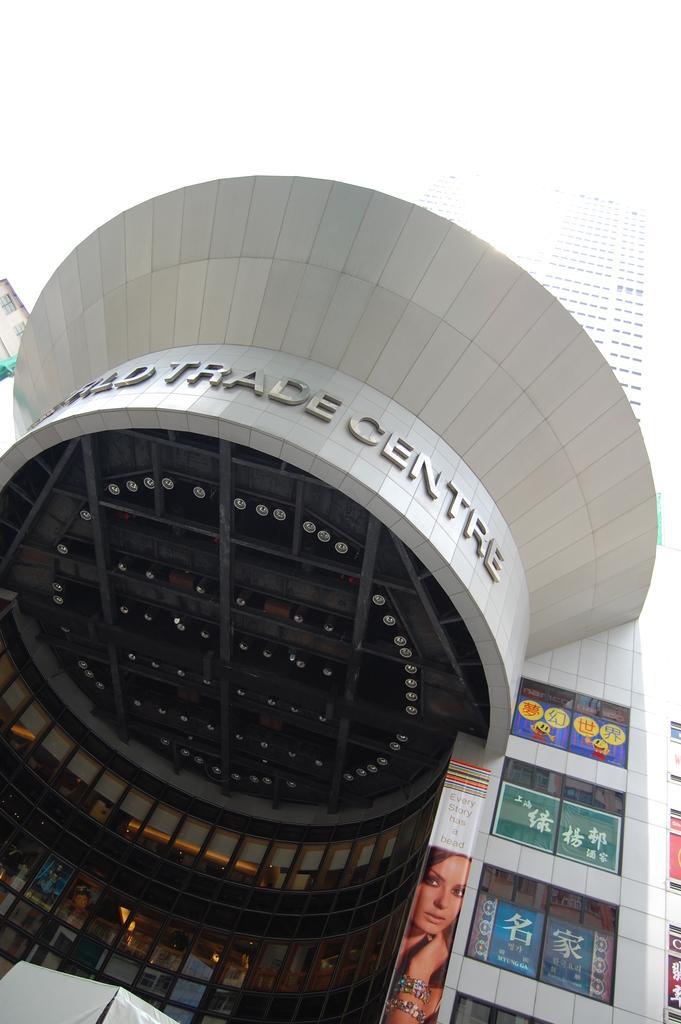Can you describe this image briefly? In the image we can see a building, on the building there are some posters. 